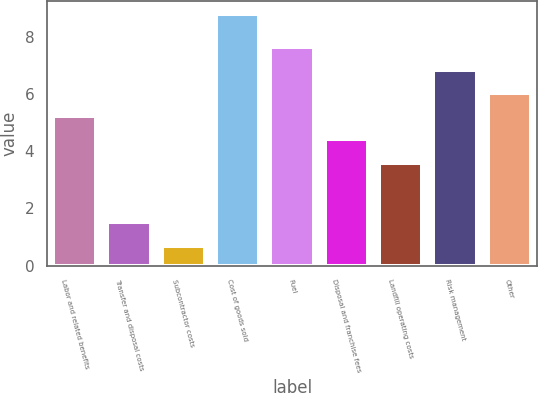Convert chart to OTSL. <chart><loc_0><loc_0><loc_500><loc_500><bar_chart><fcel>Labor and related benefits<fcel>Transfer and disposal costs<fcel>Subcontractor costs<fcel>Cost of goods sold<fcel>Fuel<fcel>Disposal and franchise fees<fcel>Landfill operating costs<fcel>Risk management<fcel>Other<nl><fcel>5.22<fcel>1.51<fcel>0.7<fcel>8.8<fcel>7.65<fcel>4.41<fcel>3.6<fcel>6.84<fcel>6.03<nl></chart> 